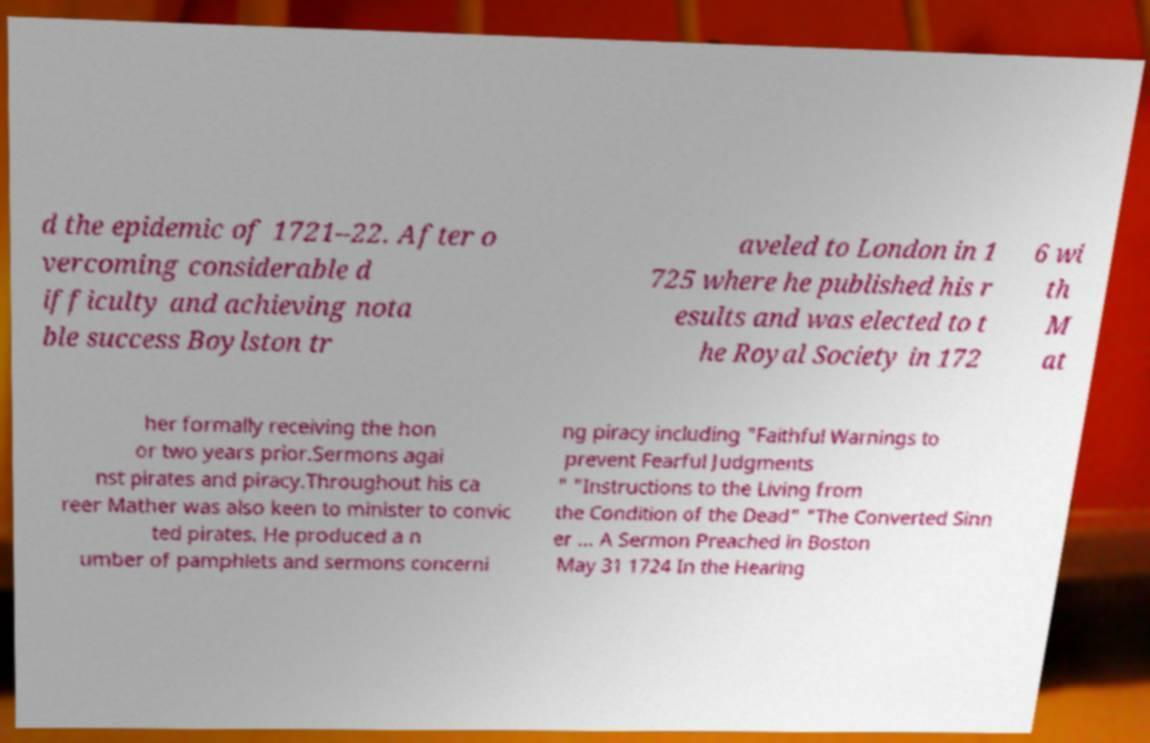I need the written content from this picture converted into text. Can you do that? d the epidemic of 1721–22. After o vercoming considerable d ifficulty and achieving nota ble success Boylston tr aveled to London in 1 725 where he published his r esults and was elected to t he Royal Society in 172 6 wi th M at her formally receiving the hon or two years prior.Sermons agai nst pirates and piracy.Throughout his ca reer Mather was also keen to minister to convic ted pirates. He produced a n umber of pamphlets and sermons concerni ng piracy including "Faithful Warnings to prevent Fearful Judgments " "Instructions to the Living from the Condition of the Dead" "The Converted Sinn er ... A Sermon Preached in Boston May 31 1724 In the Hearing 